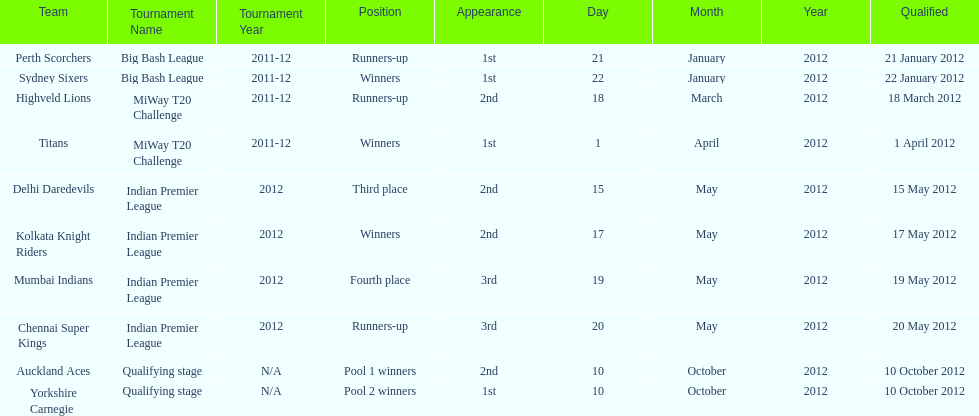Which team came in after the titans in the miway t20 challenge? Highveld Lions. Could you parse the entire table as a dict? {'header': ['Team', 'Tournament Name', 'Tournament Year', 'Position', 'Appearance', 'Day', 'Month', 'Year', 'Qualified'], 'rows': [['Perth Scorchers', 'Big Bash League', '2011-12', 'Runners-up', '1st', '21', 'January', '2012', '21 January 2012'], ['Sydney Sixers', 'Big Bash League', '2011-12', 'Winners', '1st', '22', 'January', '2012', '22 January 2012'], ['Highveld Lions', 'MiWay T20 Challenge', '2011-12', 'Runners-up', '2nd', '18', 'March', '2012', '18 March 2012'], ['Titans', 'MiWay T20 Challenge', '2011-12', 'Winners', '1st', '1', 'April', '2012', '1 April 2012'], ['Delhi Daredevils', 'Indian Premier League', '2012', 'Third place', '2nd', '15', 'May', '2012', '15 May 2012'], ['Kolkata Knight Riders', 'Indian Premier League', '2012', 'Winners', '2nd', '17', 'May', '2012', '17 May 2012'], ['Mumbai Indians', 'Indian Premier League', '2012', 'Fourth place', '3rd', '19', 'May', '2012', '19 May 2012'], ['Chennai Super Kings', 'Indian Premier League', '2012', 'Runners-up', '3rd', '20', 'May', '2012', '20 May 2012'], ['Auckland Aces', 'Qualifying stage', 'N/A', 'Pool 1 winners', '2nd', '10', 'October', '2012', '10 October 2012'], ['Yorkshire Carnegie', 'Qualifying stage', 'N/A', 'Pool 2 winners', '1st', '10', 'October', '2012', '10 October 2012']]} 